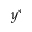Convert formula to latex. <formula><loc_0><loc_0><loc_500><loc_500>y ^ { * }</formula> 